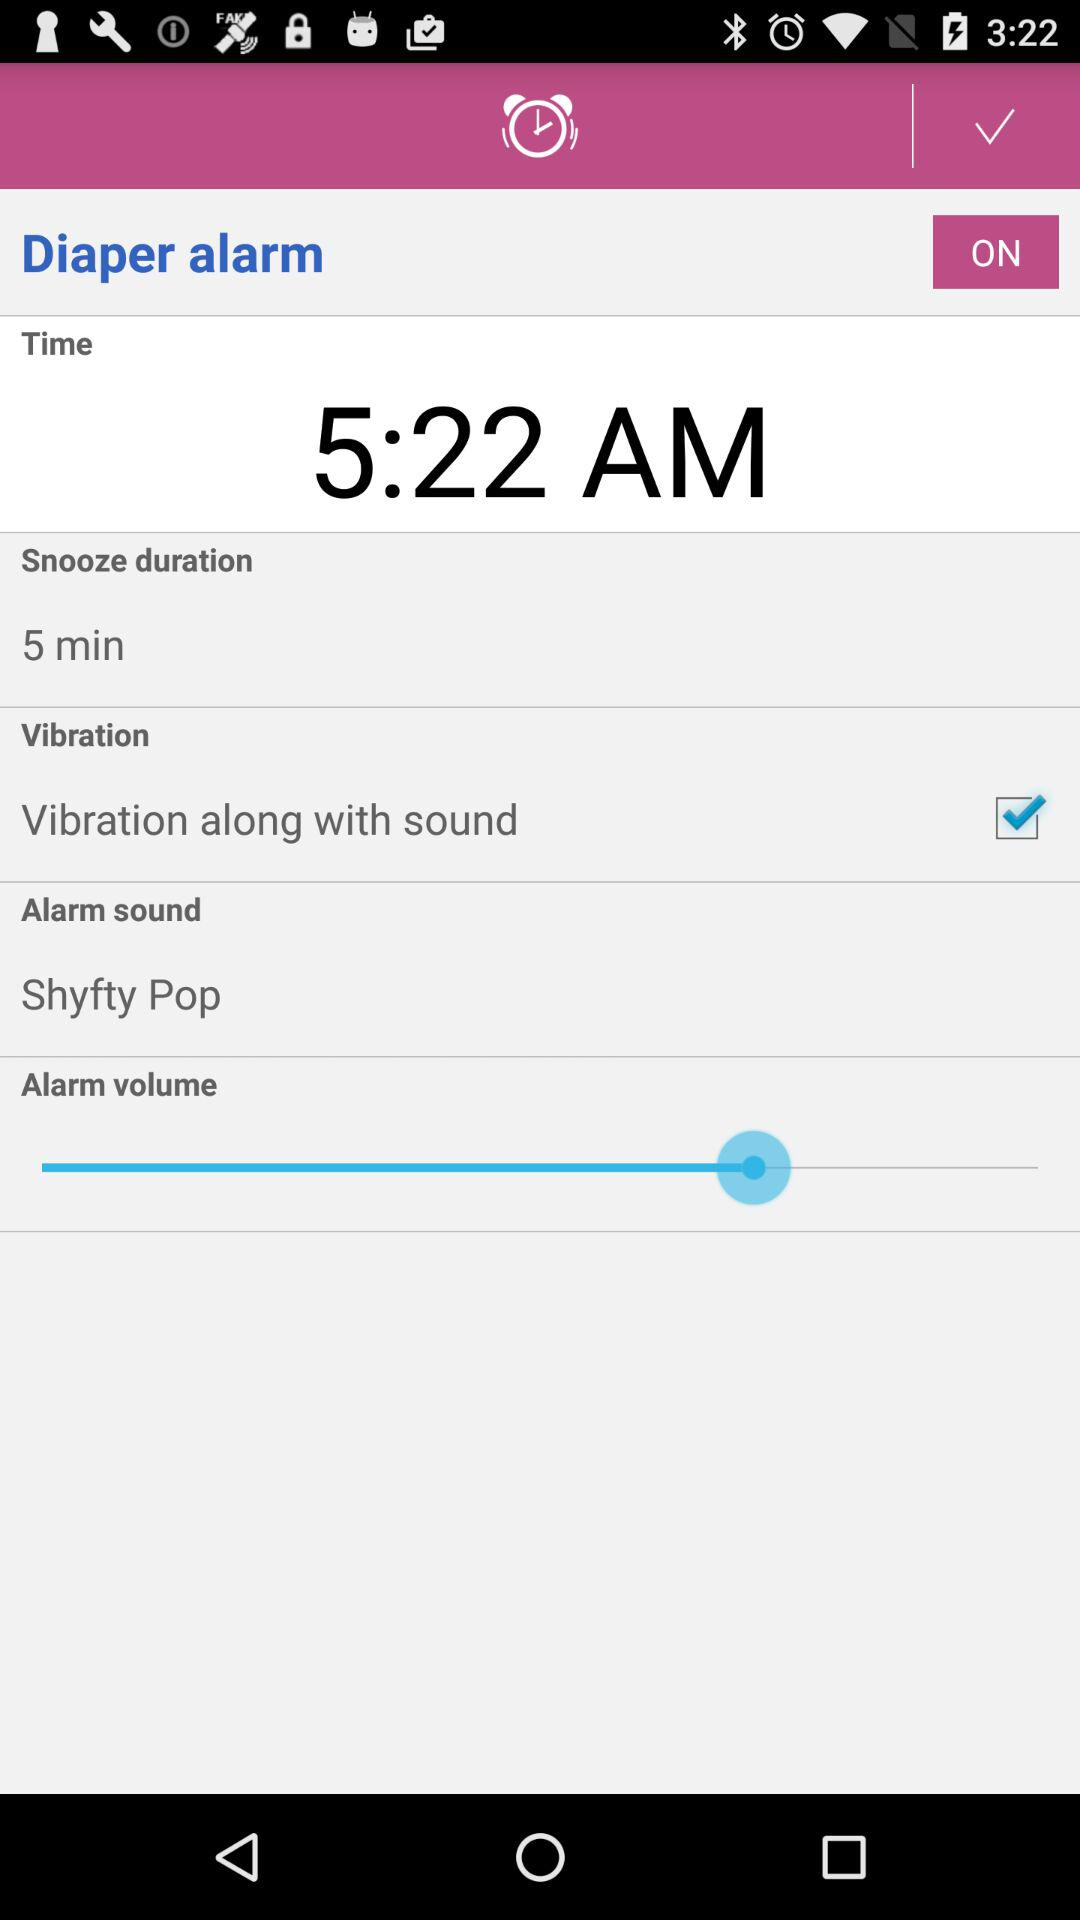What is the status of "Vibration along with sound"? The status is "on". 